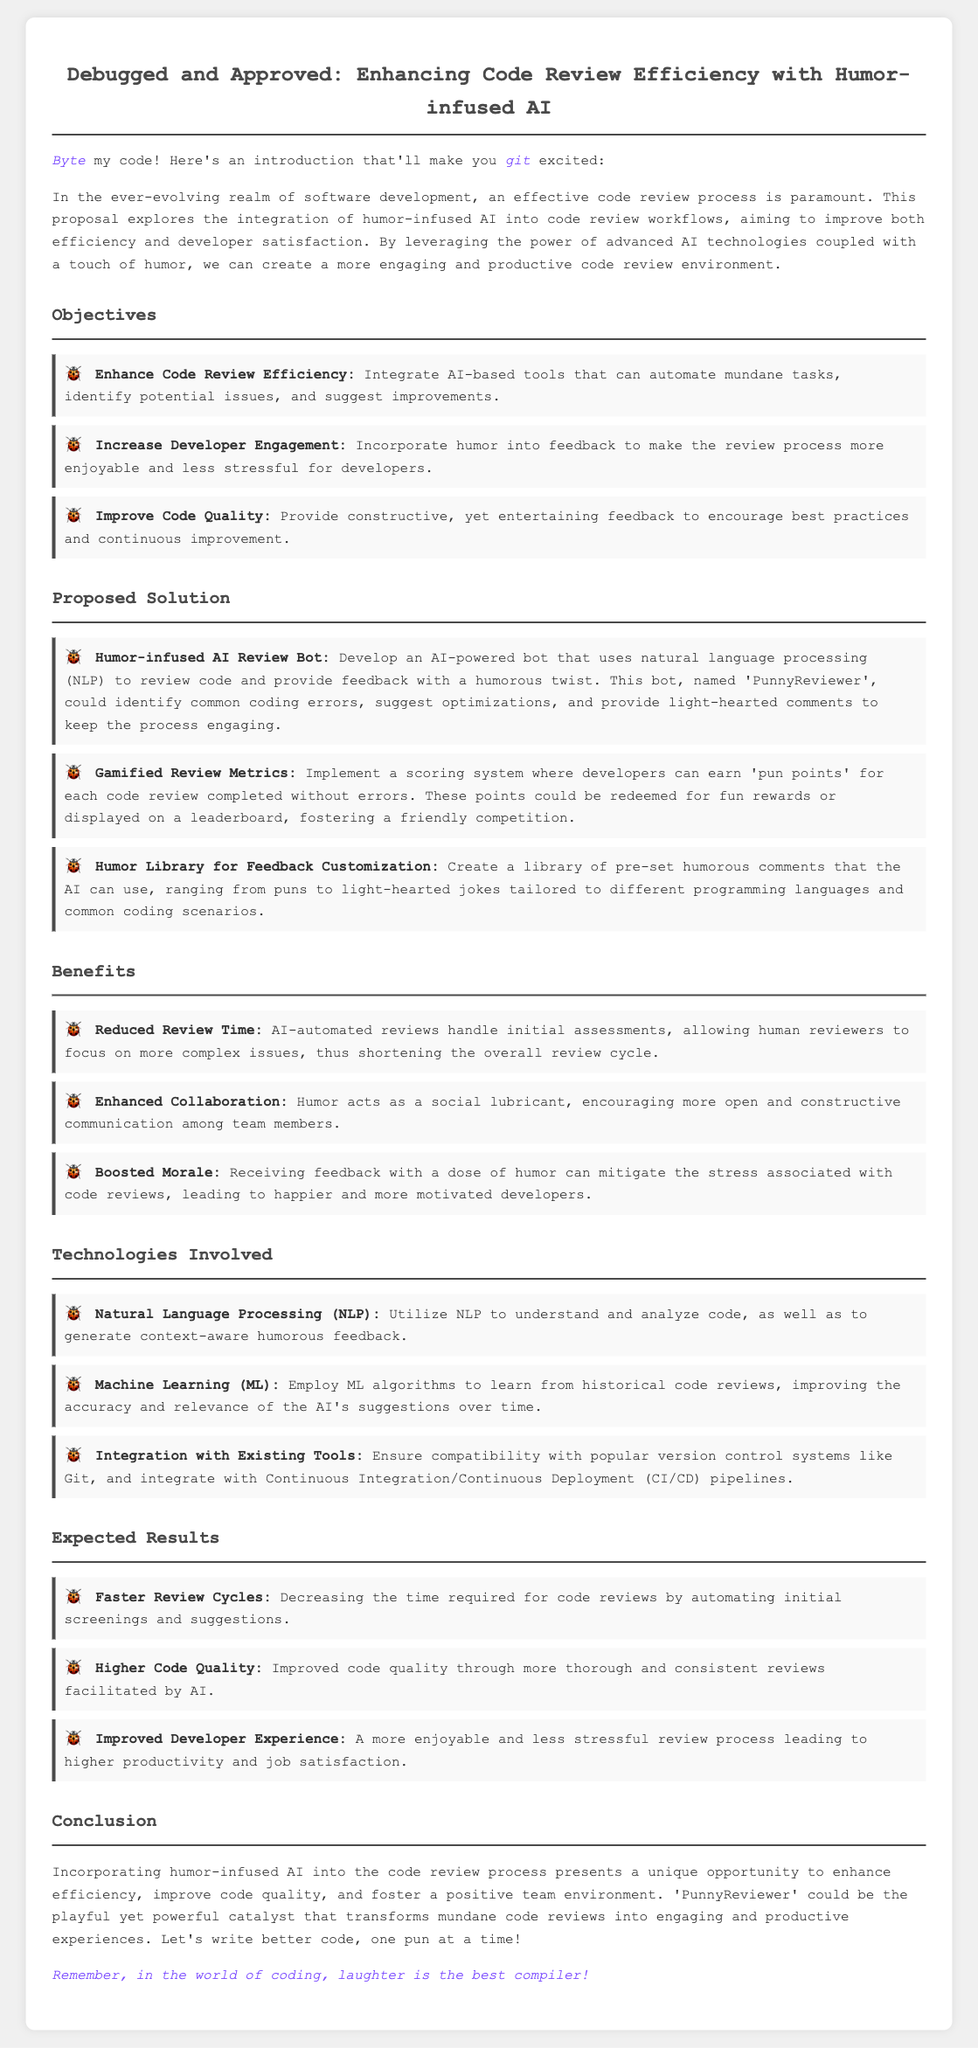What is the title of the proposal? The title of the proposal can be found at the top of the document.
Answer: Debugged and Approved: Enhancing Code Review Efficiency with Humor-infused AI Who is the proposed AI review bot named? The document specifies a name for the AI review bot that will be developed.
Answer: PunnyReviewer What is one objective of the proposal? The proposal lists multiple objectives related to code reviews; one of them can be extracted from the document.
Answer: Enhance Code Review Efficiency What technology is mentioned for analyzing code? The document describes a technology utilized in the proposal.
Answer: Natural Language Processing (NLP) What is a benefit of integrating humor into code reviews? The proposal articulates certain benefits, one of which can be stated from the document.
Answer: Boosted Morale How many proposed solutions are there? The number of solutions is indicated within a specific section of the document.
Answer: Three 